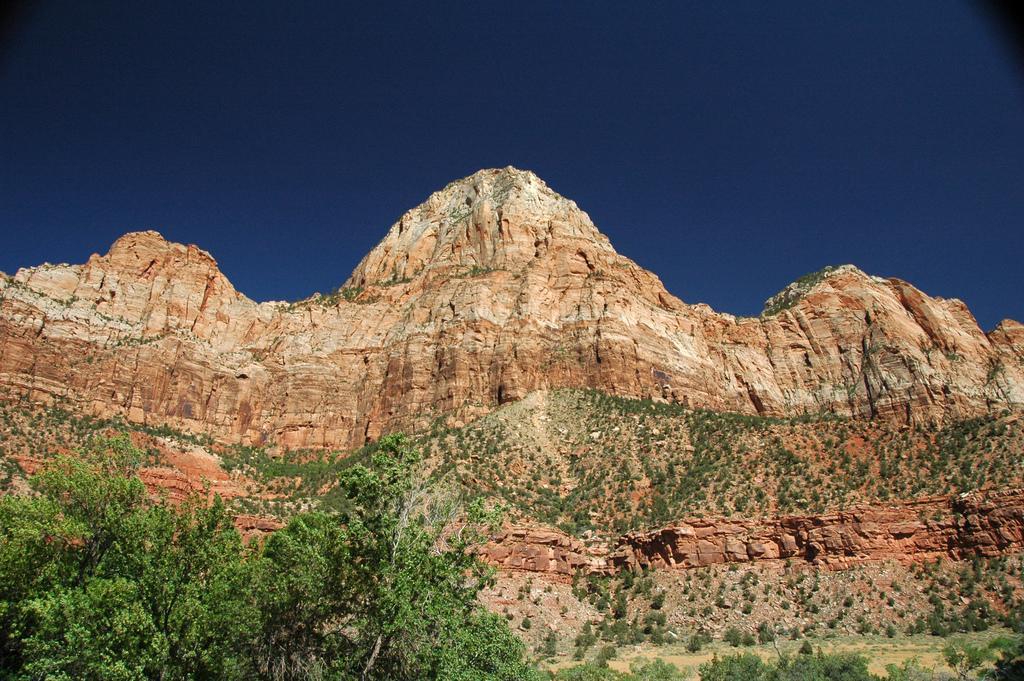Could you give a brief overview of what you see in this image? In this image in front there are trees. In the background of the image there are mountains and sky. 